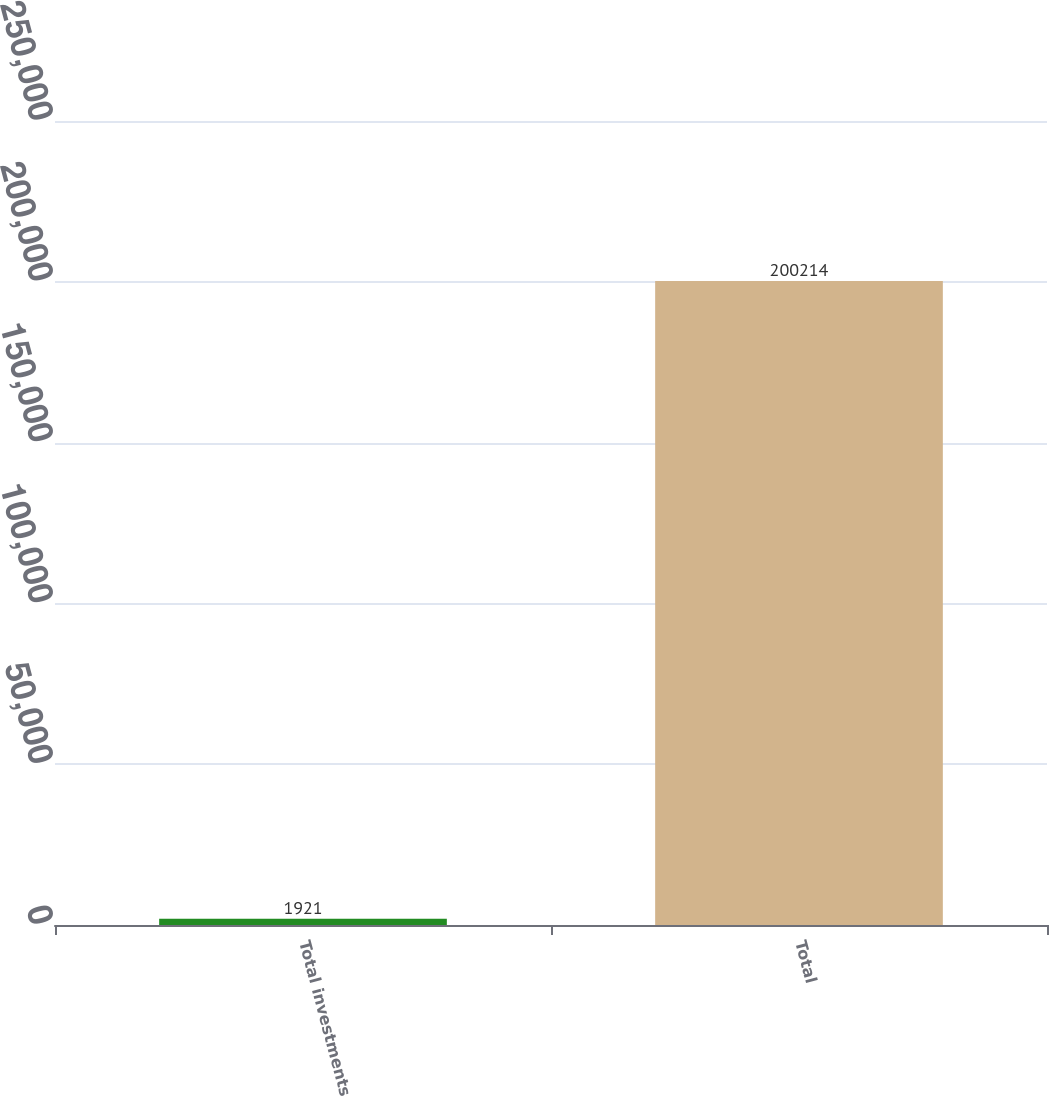Convert chart. <chart><loc_0><loc_0><loc_500><loc_500><bar_chart><fcel>Total investments<fcel>Total<nl><fcel>1921<fcel>200214<nl></chart> 